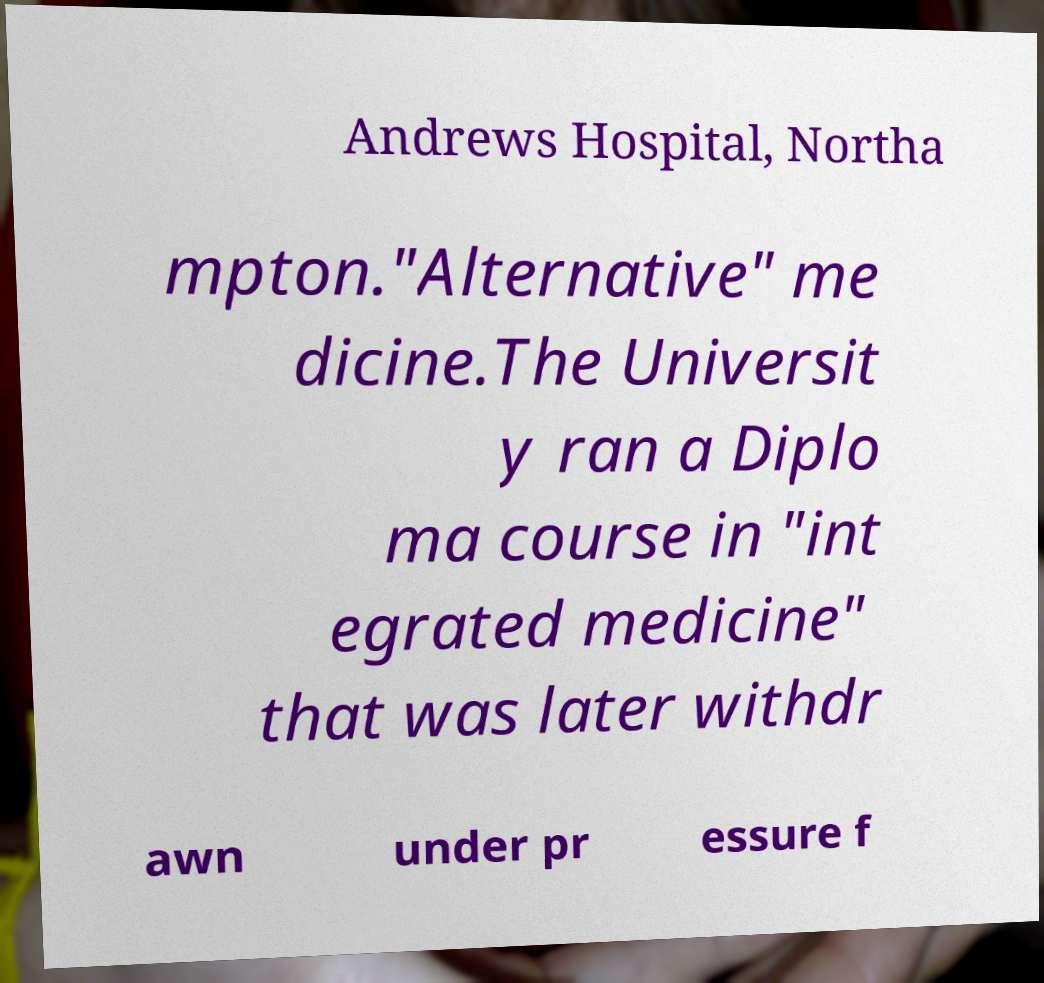Could you extract and type out the text from this image? Andrews Hospital, Northa mpton."Alternative" me dicine.The Universit y ran a Diplo ma course in "int egrated medicine" that was later withdr awn under pr essure f 